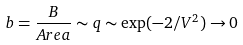Convert formula to latex. <formula><loc_0><loc_0><loc_500><loc_500>b = \frac { B } { A r e a } \sim q \sim \exp ( - 2 / V ^ { 2 } ) \rightarrow 0</formula> 